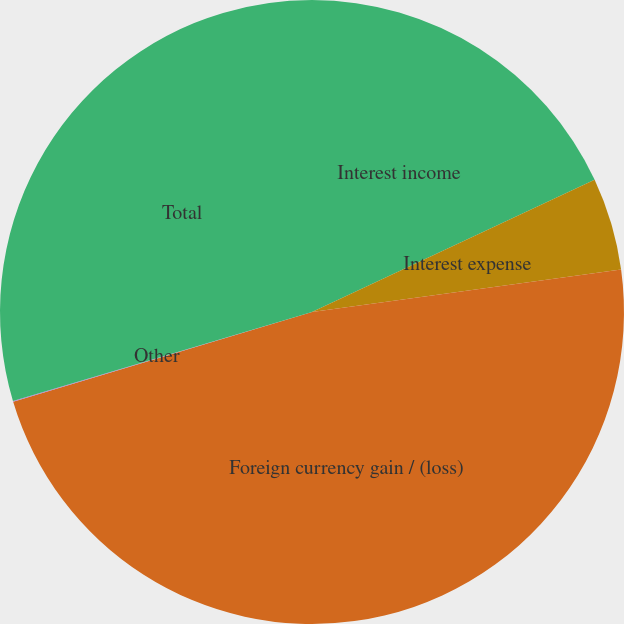Convert chart. <chart><loc_0><loc_0><loc_500><loc_500><pie_chart><fcel>Interest income<fcel>Interest expense<fcel>Foreign currency gain / (loss)<fcel>Other<fcel>Total<nl><fcel>18.04%<fcel>4.79%<fcel>47.53%<fcel>0.04%<fcel>29.6%<nl></chart> 